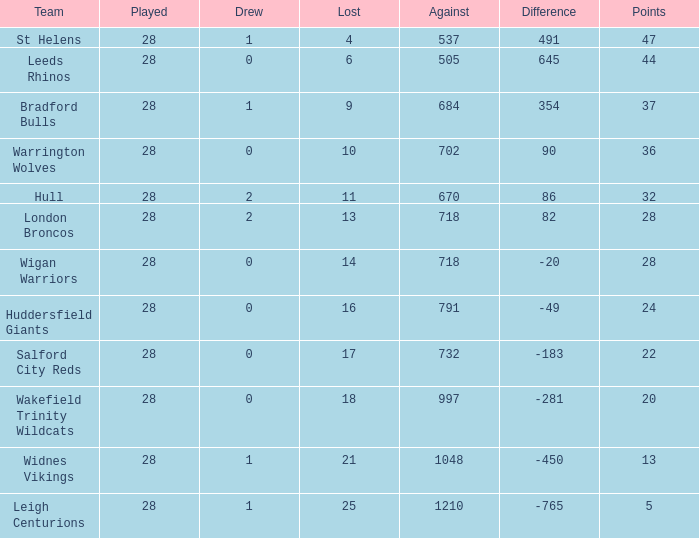For a team with 32 points and a point difference under 86, what is the highest number of games they have lost? None. 